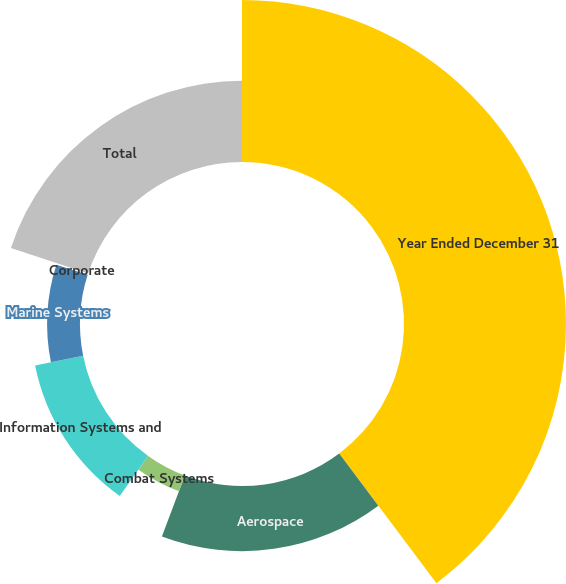<chart> <loc_0><loc_0><loc_500><loc_500><pie_chart><fcel>Year Ended December 31<fcel>Aerospace<fcel>Combat Systems<fcel>Information Systems and<fcel>Marine Systems<fcel>Corporate<fcel>Total<nl><fcel>39.75%<fcel>15.98%<fcel>4.1%<fcel>12.02%<fcel>8.06%<fcel>0.14%<fcel>19.94%<nl></chart> 